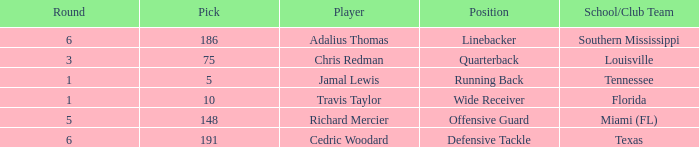What's the highest round that louisville drafted into when their pick was over 75? None. 